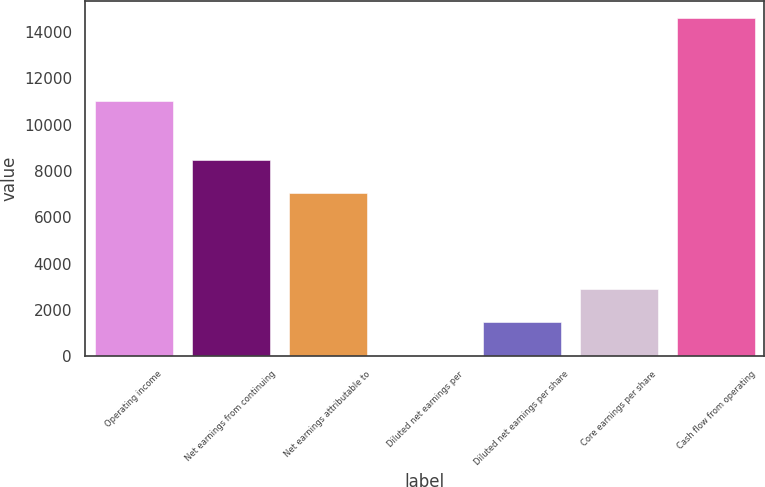<chart> <loc_0><loc_0><loc_500><loc_500><bar_chart><fcel>Operating income<fcel>Net earnings from continuing<fcel>Net earnings attributable to<fcel>Diluted net earnings per<fcel>Diluted net earnings per share<fcel>Core earnings per share<fcel>Cash flow from operating<nl><fcel>11049<fcel>8496.56<fcel>7036<fcel>2.44<fcel>1463<fcel>2923.56<fcel>14608<nl></chart> 